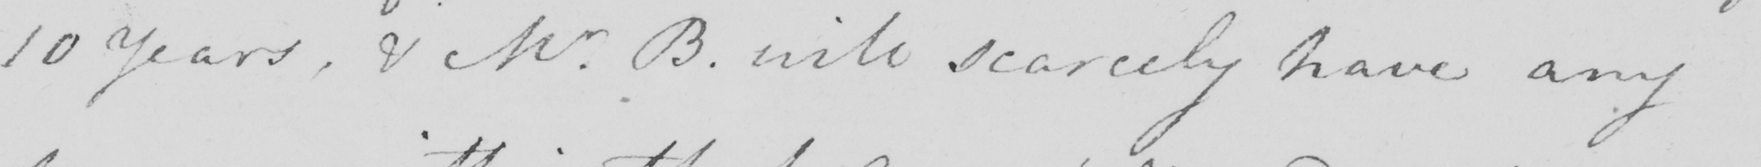Please transcribe the handwritten text in this image. 10 years , & Mr . B . will scarcely have any 